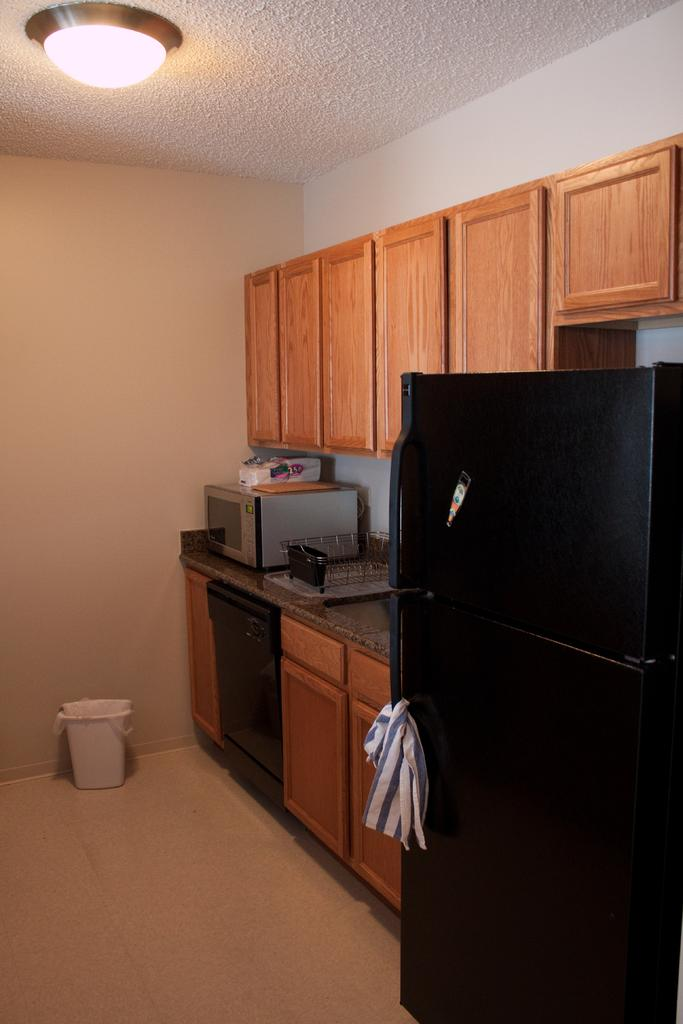What type of appliance can be seen in the image? There is an oven in the image. What is located on the countertop in the image? There are objects placed on the countertop. What other appliance is visible in the image? There is a refrigerator in the image. What type of storage is present in the image? There are cupboards in the image. What is used for waste disposal in the image? There is a trash bin in the image. What architectural feature is present in the image? There is a wall in the image. What type of lighting is present in the image? There is a ceiling light in the image. How many lizards can be seen crawling on the oven in the image? There are no lizards present in the image; it only features an oven, objects on the countertop, a refrigerator, cupboards, a trash bin, a wall, and a ceiling light. What type of drug is being prepared in the image? There is no drug preparation or any reference to drugs in the image. 